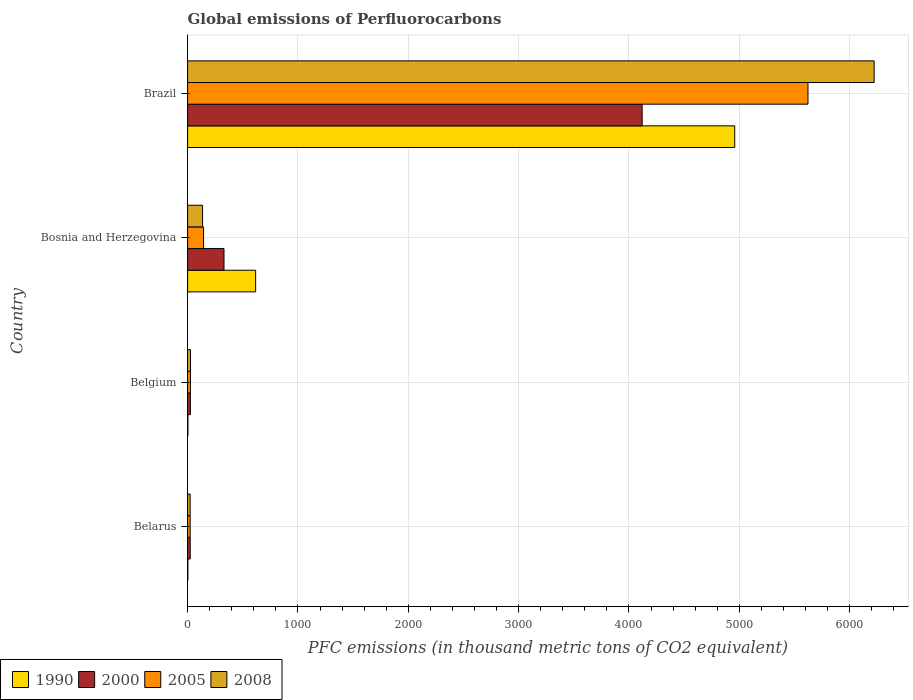How many different coloured bars are there?
Offer a terse response. 4. How many groups of bars are there?
Offer a very short reply. 4. Are the number of bars on each tick of the Y-axis equal?
Give a very brief answer. Yes. What is the label of the 4th group of bars from the top?
Give a very brief answer. Belarus. What is the global emissions of Perfluorocarbons in 1990 in Bosnia and Herzegovina?
Offer a terse response. 616.7. Across all countries, what is the maximum global emissions of Perfluorocarbons in 2008?
Your response must be concise. 6221.8. Across all countries, what is the minimum global emissions of Perfluorocarbons in 2008?
Provide a succinct answer. 23.1. In which country was the global emissions of Perfluorocarbons in 2000 maximum?
Offer a very short reply. Brazil. In which country was the global emissions of Perfluorocarbons in 1990 minimum?
Offer a very short reply. Belarus. What is the total global emissions of Perfluorocarbons in 1990 in the graph?
Provide a short and direct response. 5580.3. What is the difference between the global emissions of Perfluorocarbons in 2008 in Belgium and that in Bosnia and Herzegovina?
Ensure brevity in your answer.  -109.6. What is the difference between the global emissions of Perfluorocarbons in 2000 in Bosnia and Herzegovina and the global emissions of Perfluorocarbons in 2008 in Belgium?
Make the answer very short. 303.9. What is the average global emissions of Perfluorocarbons in 1990 per country?
Your answer should be compact. 1395.08. What is the difference between the global emissions of Perfluorocarbons in 2000 and global emissions of Perfluorocarbons in 2008 in Bosnia and Herzegovina?
Offer a terse response. 194.3. What is the ratio of the global emissions of Perfluorocarbons in 1990 in Belarus to that in Bosnia and Herzegovina?
Ensure brevity in your answer.  0. Is the global emissions of Perfluorocarbons in 2008 in Belarus less than that in Brazil?
Your answer should be compact. Yes. Is the difference between the global emissions of Perfluorocarbons in 2000 in Belarus and Bosnia and Herzegovina greater than the difference between the global emissions of Perfluorocarbons in 2008 in Belarus and Bosnia and Herzegovina?
Ensure brevity in your answer.  No. What is the difference between the highest and the second highest global emissions of Perfluorocarbons in 2005?
Keep it short and to the point. 5477.7. What is the difference between the highest and the lowest global emissions of Perfluorocarbons in 2008?
Offer a very short reply. 6198.7. In how many countries, is the global emissions of Perfluorocarbons in 2008 greater than the average global emissions of Perfluorocarbons in 2008 taken over all countries?
Keep it short and to the point. 1. Is the sum of the global emissions of Perfluorocarbons in 2000 in Belarus and Belgium greater than the maximum global emissions of Perfluorocarbons in 1990 across all countries?
Your answer should be very brief. No. What does the 1st bar from the bottom in Belgium represents?
Give a very brief answer. 1990. Is it the case that in every country, the sum of the global emissions of Perfluorocarbons in 2005 and global emissions of Perfluorocarbons in 2000 is greater than the global emissions of Perfluorocarbons in 1990?
Provide a short and direct response. No. How many bars are there?
Provide a short and direct response. 16. How many countries are there in the graph?
Keep it short and to the point. 4. What is the difference between two consecutive major ticks on the X-axis?
Keep it short and to the point. 1000. Does the graph contain grids?
Offer a terse response. Yes. How many legend labels are there?
Ensure brevity in your answer.  4. How are the legend labels stacked?
Provide a succinct answer. Horizontal. What is the title of the graph?
Your answer should be very brief. Global emissions of Perfluorocarbons. Does "1971" appear as one of the legend labels in the graph?
Ensure brevity in your answer.  No. What is the label or title of the X-axis?
Provide a succinct answer. PFC emissions (in thousand metric tons of CO2 equivalent). What is the label or title of the Y-axis?
Give a very brief answer. Country. What is the PFC emissions (in thousand metric tons of CO2 equivalent) in 1990 in Belarus?
Keep it short and to the point. 2.6. What is the PFC emissions (in thousand metric tons of CO2 equivalent) in 2000 in Belarus?
Your response must be concise. 23.9. What is the PFC emissions (in thousand metric tons of CO2 equivalent) in 2005 in Belarus?
Ensure brevity in your answer.  23.4. What is the PFC emissions (in thousand metric tons of CO2 equivalent) in 2008 in Belarus?
Your answer should be very brief. 23.1. What is the PFC emissions (in thousand metric tons of CO2 equivalent) of 2000 in Belgium?
Provide a short and direct response. 25.2. What is the PFC emissions (in thousand metric tons of CO2 equivalent) of 2005 in Belgium?
Offer a terse response. 25.7. What is the PFC emissions (in thousand metric tons of CO2 equivalent) in 2008 in Belgium?
Give a very brief answer. 26. What is the PFC emissions (in thousand metric tons of CO2 equivalent) of 1990 in Bosnia and Herzegovina?
Ensure brevity in your answer.  616.7. What is the PFC emissions (in thousand metric tons of CO2 equivalent) of 2000 in Bosnia and Herzegovina?
Ensure brevity in your answer.  329.9. What is the PFC emissions (in thousand metric tons of CO2 equivalent) in 2005 in Bosnia and Herzegovina?
Make the answer very short. 144.4. What is the PFC emissions (in thousand metric tons of CO2 equivalent) in 2008 in Bosnia and Herzegovina?
Offer a very short reply. 135.6. What is the PFC emissions (in thousand metric tons of CO2 equivalent) of 1990 in Brazil?
Offer a terse response. 4958.1. What is the PFC emissions (in thousand metric tons of CO2 equivalent) of 2000 in Brazil?
Provide a succinct answer. 4119.1. What is the PFC emissions (in thousand metric tons of CO2 equivalent) in 2005 in Brazil?
Offer a very short reply. 5622.1. What is the PFC emissions (in thousand metric tons of CO2 equivalent) in 2008 in Brazil?
Your answer should be compact. 6221.8. Across all countries, what is the maximum PFC emissions (in thousand metric tons of CO2 equivalent) of 1990?
Your answer should be very brief. 4958.1. Across all countries, what is the maximum PFC emissions (in thousand metric tons of CO2 equivalent) in 2000?
Your answer should be very brief. 4119.1. Across all countries, what is the maximum PFC emissions (in thousand metric tons of CO2 equivalent) of 2005?
Your answer should be compact. 5622.1. Across all countries, what is the maximum PFC emissions (in thousand metric tons of CO2 equivalent) in 2008?
Your answer should be very brief. 6221.8. Across all countries, what is the minimum PFC emissions (in thousand metric tons of CO2 equivalent) of 2000?
Give a very brief answer. 23.9. Across all countries, what is the minimum PFC emissions (in thousand metric tons of CO2 equivalent) of 2005?
Offer a terse response. 23.4. Across all countries, what is the minimum PFC emissions (in thousand metric tons of CO2 equivalent) in 2008?
Offer a terse response. 23.1. What is the total PFC emissions (in thousand metric tons of CO2 equivalent) in 1990 in the graph?
Provide a short and direct response. 5580.3. What is the total PFC emissions (in thousand metric tons of CO2 equivalent) in 2000 in the graph?
Ensure brevity in your answer.  4498.1. What is the total PFC emissions (in thousand metric tons of CO2 equivalent) in 2005 in the graph?
Offer a very short reply. 5815.6. What is the total PFC emissions (in thousand metric tons of CO2 equivalent) of 2008 in the graph?
Your answer should be compact. 6406.5. What is the difference between the PFC emissions (in thousand metric tons of CO2 equivalent) of 1990 in Belarus and that in Belgium?
Make the answer very short. -0.3. What is the difference between the PFC emissions (in thousand metric tons of CO2 equivalent) in 2000 in Belarus and that in Belgium?
Your answer should be compact. -1.3. What is the difference between the PFC emissions (in thousand metric tons of CO2 equivalent) of 2005 in Belarus and that in Belgium?
Provide a succinct answer. -2.3. What is the difference between the PFC emissions (in thousand metric tons of CO2 equivalent) in 1990 in Belarus and that in Bosnia and Herzegovina?
Provide a short and direct response. -614.1. What is the difference between the PFC emissions (in thousand metric tons of CO2 equivalent) of 2000 in Belarus and that in Bosnia and Herzegovina?
Keep it short and to the point. -306. What is the difference between the PFC emissions (in thousand metric tons of CO2 equivalent) of 2005 in Belarus and that in Bosnia and Herzegovina?
Ensure brevity in your answer.  -121. What is the difference between the PFC emissions (in thousand metric tons of CO2 equivalent) in 2008 in Belarus and that in Bosnia and Herzegovina?
Provide a short and direct response. -112.5. What is the difference between the PFC emissions (in thousand metric tons of CO2 equivalent) in 1990 in Belarus and that in Brazil?
Offer a very short reply. -4955.5. What is the difference between the PFC emissions (in thousand metric tons of CO2 equivalent) in 2000 in Belarus and that in Brazil?
Offer a terse response. -4095.2. What is the difference between the PFC emissions (in thousand metric tons of CO2 equivalent) of 2005 in Belarus and that in Brazil?
Provide a succinct answer. -5598.7. What is the difference between the PFC emissions (in thousand metric tons of CO2 equivalent) in 2008 in Belarus and that in Brazil?
Your answer should be very brief. -6198.7. What is the difference between the PFC emissions (in thousand metric tons of CO2 equivalent) in 1990 in Belgium and that in Bosnia and Herzegovina?
Keep it short and to the point. -613.8. What is the difference between the PFC emissions (in thousand metric tons of CO2 equivalent) of 2000 in Belgium and that in Bosnia and Herzegovina?
Offer a very short reply. -304.7. What is the difference between the PFC emissions (in thousand metric tons of CO2 equivalent) in 2005 in Belgium and that in Bosnia and Herzegovina?
Offer a terse response. -118.7. What is the difference between the PFC emissions (in thousand metric tons of CO2 equivalent) in 2008 in Belgium and that in Bosnia and Herzegovina?
Your answer should be very brief. -109.6. What is the difference between the PFC emissions (in thousand metric tons of CO2 equivalent) in 1990 in Belgium and that in Brazil?
Your answer should be very brief. -4955.2. What is the difference between the PFC emissions (in thousand metric tons of CO2 equivalent) of 2000 in Belgium and that in Brazil?
Ensure brevity in your answer.  -4093.9. What is the difference between the PFC emissions (in thousand metric tons of CO2 equivalent) of 2005 in Belgium and that in Brazil?
Provide a short and direct response. -5596.4. What is the difference between the PFC emissions (in thousand metric tons of CO2 equivalent) of 2008 in Belgium and that in Brazil?
Provide a succinct answer. -6195.8. What is the difference between the PFC emissions (in thousand metric tons of CO2 equivalent) of 1990 in Bosnia and Herzegovina and that in Brazil?
Provide a succinct answer. -4341.4. What is the difference between the PFC emissions (in thousand metric tons of CO2 equivalent) in 2000 in Bosnia and Herzegovina and that in Brazil?
Offer a terse response. -3789.2. What is the difference between the PFC emissions (in thousand metric tons of CO2 equivalent) of 2005 in Bosnia and Herzegovina and that in Brazil?
Provide a short and direct response. -5477.7. What is the difference between the PFC emissions (in thousand metric tons of CO2 equivalent) in 2008 in Bosnia and Herzegovina and that in Brazil?
Your answer should be very brief. -6086.2. What is the difference between the PFC emissions (in thousand metric tons of CO2 equivalent) of 1990 in Belarus and the PFC emissions (in thousand metric tons of CO2 equivalent) of 2000 in Belgium?
Offer a very short reply. -22.6. What is the difference between the PFC emissions (in thousand metric tons of CO2 equivalent) of 1990 in Belarus and the PFC emissions (in thousand metric tons of CO2 equivalent) of 2005 in Belgium?
Provide a succinct answer. -23.1. What is the difference between the PFC emissions (in thousand metric tons of CO2 equivalent) of 1990 in Belarus and the PFC emissions (in thousand metric tons of CO2 equivalent) of 2008 in Belgium?
Make the answer very short. -23.4. What is the difference between the PFC emissions (in thousand metric tons of CO2 equivalent) of 2000 in Belarus and the PFC emissions (in thousand metric tons of CO2 equivalent) of 2008 in Belgium?
Provide a succinct answer. -2.1. What is the difference between the PFC emissions (in thousand metric tons of CO2 equivalent) in 2005 in Belarus and the PFC emissions (in thousand metric tons of CO2 equivalent) in 2008 in Belgium?
Make the answer very short. -2.6. What is the difference between the PFC emissions (in thousand metric tons of CO2 equivalent) in 1990 in Belarus and the PFC emissions (in thousand metric tons of CO2 equivalent) in 2000 in Bosnia and Herzegovina?
Keep it short and to the point. -327.3. What is the difference between the PFC emissions (in thousand metric tons of CO2 equivalent) in 1990 in Belarus and the PFC emissions (in thousand metric tons of CO2 equivalent) in 2005 in Bosnia and Herzegovina?
Your answer should be very brief. -141.8. What is the difference between the PFC emissions (in thousand metric tons of CO2 equivalent) of 1990 in Belarus and the PFC emissions (in thousand metric tons of CO2 equivalent) of 2008 in Bosnia and Herzegovina?
Provide a succinct answer. -133. What is the difference between the PFC emissions (in thousand metric tons of CO2 equivalent) in 2000 in Belarus and the PFC emissions (in thousand metric tons of CO2 equivalent) in 2005 in Bosnia and Herzegovina?
Provide a succinct answer. -120.5. What is the difference between the PFC emissions (in thousand metric tons of CO2 equivalent) in 2000 in Belarus and the PFC emissions (in thousand metric tons of CO2 equivalent) in 2008 in Bosnia and Herzegovina?
Make the answer very short. -111.7. What is the difference between the PFC emissions (in thousand metric tons of CO2 equivalent) in 2005 in Belarus and the PFC emissions (in thousand metric tons of CO2 equivalent) in 2008 in Bosnia and Herzegovina?
Offer a very short reply. -112.2. What is the difference between the PFC emissions (in thousand metric tons of CO2 equivalent) in 1990 in Belarus and the PFC emissions (in thousand metric tons of CO2 equivalent) in 2000 in Brazil?
Make the answer very short. -4116.5. What is the difference between the PFC emissions (in thousand metric tons of CO2 equivalent) of 1990 in Belarus and the PFC emissions (in thousand metric tons of CO2 equivalent) of 2005 in Brazil?
Your answer should be compact. -5619.5. What is the difference between the PFC emissions (in thousand metric tons of CO2 equivalent) of 1990 in Belarus and the PFC emissions (in thousand metric tons of CO2 equivalent) of 2008 in Brazil?
Your answer should be very brief. -6219.2. What is the difference between the PFC emissions (in thousand metric tons of CO2 equivalent) of 2000 in Belarus and the PFC emissions (in thousand metric tons of CO2 equivalent) of 2005 in Brazil?
Make the answer very short. -5598.2. What is the difference between the PFC emissions (in thousand metric tons of CO2 equivalent) in 2000 in Belarus and the PFC emissions (in thousand metric tons of CO2 equivalent) in 2008 in Brazil?
Your answer should be compact. -6197.9. What is the difference between the PFC emissions (in thousand metric tons of CO2 equivalent) of 2005 in Belarus and the PFC emissions (in thousand metric tons of CO2 equivalent) of 2008 in Brazil?
Your answer should be very brief. -6198.4. What is the difference between the PFC emissions (in thousand metric tons of CO2 equivalent) of 1990 in Belgium and the PFC emissions (in thousand metric tons of CO2 equivalent) of 2000 in Bosnia and Herzegovina?
Ensure brevity in your answer.  -327. What is the difference between the PFC emissions (in thousand metric tons of CO2 equivalent) in 1990 in Belgium and the PFC emissions (in thousand metric tons of CO2 equivalent) in 2005 in Bosnia and Herzegovina?
Offer a terse response. -141.5. What is the difference between the PFC emissions (in thousand metric tons of CO2 equivalent) in 1990 in Belgium and the PFC emissions (in thousand metric tons of CO2 equivalent) in 2008 in Bosnia and Herzegovina?
Provide a short and direct response. -132.7. What is the difference between the PFC emissions (in thousand metric tons of CO2 equivalent) of 2000 in Belgium and the PFC emissions (in thousand metric tons of CO2 equivalent) of 2005 in Bosnia and Herzegovina?
Your response must be concise. -119.2. What is the difference between the PFC emissions (in thousand metric tons of CO2 equivalent) in 2000 in Belgium and the PFC emissions (in thousand metric tons of CO2 equivalent) in 2008 in Bosnia and Herzegovina?
Offer a terse response. -110.4. What is the difference between the PFC emissions (in thousand metric tons of CO2 equivalent) of 2005 in Belgium and the PFC emissions (in thousand metric tons of CO2 equivalent) of 2008 in Bosnia and Herzegovina?
Your response must be concise. -109.9. What is the difference between the PFC emissions (in thousand metric tons of CO2 equivalent) of 1990 in Belgium and the PFC emissions (in thousand metric tons of CO2 equivalent) of 2000 in Brazil?
Ensure brevity in your answer.  -4116.2. What is the difference between the PFC emissions (in thousand metric tons of CO2 equivalent) of 1990 in Belgium and the PFC emissions (in thousand metric tons of CO2 equivalent) of 2005 in Brazil?
Your answer should be compact. -5619.2. What is the difference between the PFC emissions (in thousand metric tons of CO2 equivalent) of 1990 in Belgium and the PFC emissions (in thousand metric tons of CO2 equivalent) of 2008 in Brazil?
Your answer should be very brief. -6218.9. What is the difference between the PFC emissions (in thousand metric tons of CO2 equivalent) in 2000 in Belgium and the PFC emissions (in thousand metric tons of CO2 equivalent) in 2005 in Brazil?
Your response must be concise. -5596.9. What is the difference between the PFC emissions (in thousand metric tons of CO2 equivalent) of 2000 in Belgium and the PFC emissions (in thousand metric tons of CO2 equivalent) of 2008 in Brazil?
Offer a very short reply. -6196.6. What is the difference between the PFC emissions (in thousand metric tons of CO2 equivalent) in 2005 in Belgium and the PFC emissions (in thousand metric tons of CO2 equivalent) in 2008 in Brazil?
Your answer should be compact. -6196.1. What is the difference between the PFC emissions (in thousand metric tons of CO2 equivalent) of 1990 in Bosnia and Herzegovina and the PFC emissions (in thousand metric tons of CO2 equivalent) of 2000 in Brazil?
Offer a terse response. -3502.4. What is the difference between the PFC emissions (in thousand metric tons of CO2 equivalent) of 1990 in Bosnia and Herzegovina and the PFC emissions (in thousand metric tons of CO2 equivalent) of 2005 in Brazil?
Your response must be concise. -5005.4. What is the difference between the PFC emissions (in thousand metric tons of CO2 equivalent) of 1990 in Bosnia and Herzegovina and the PFC emissions (in thousand metric tons of CO2 equivalent) of 2008 in Brazil?
Offer a terse response. -5605.1. What is the difference between the PFC emissions (in thousand metric tons of CO2 equivalent) of 2000 in Bosnia and Herzegovina and the PFC emissions (in thousand metric tons of CO2 equivalent) of 2005 in Brazil?
Ensure brevity in your answer.  -5292.2. What is the difference between the PFC emissions (in thousand metric tons of CO2 equivalent) of 2000 in Bosnia and Herzegovina and the PFC emissions (in thousand metric tons of CO2 equivalent) of 2008 in Brazil?
Give a very brief answer. -5891.9. What is the difference between the PFC emissions (in thousand metric tons of CO2 equivalent) in 2005 in Bosnia and Herzegovina and the PFC emissions (in thousand metric tons of CO2 equivalent) in 2008 in Brazil?
Offer a terse response. -6077.4. What is the average PFC emissions (in thousand metric tons of CO2 equivalent) in 1990 per country?
Make the answer very short. 1395.08. What is the average PFC emissions (in thousand metric tons of CO2 equivalent) in 2000 per country?
Offer a terse response. 1124.53. What is the average PFC emissions (in thousand metric tons of CO2 equivalent) in 2005 per country?
Offer a terse response. 1453.9. What is the average PFC emissions (in thousand metric tons of CO2 equivalent) in 2008 per country?
Provide a succinct answer. 1601.62. What is the difference between the PFC emissions (in thousand metric tons of CO2 equivalent) of 1990 and PFC emissions (in thousand metric tons of CO2 equivalent) of 2000 in Belarus?
Make the answer very short. -21.3. What is the difference between the PFC emissions (in thousand metric tons of CO2 equivalent) of 1990 and PFC emissions (in thousand metric tons of CO2 equivalent) of 2005 in Belarus?
Your answer should be very brief. -20.8. What is the difference between the PFC emissions (in thousand metric tons of CO2 equivalent) of 1990 and PFC emissions (in thousand metric tons of CO2 equivalent) of 2008 in Belarus?
Your answer should be very brief. -20.5. What is the difference between the PFC emissions (in thousand metric tons of CO2 equivalent) in 2000 and PFC emissions (in thousand metric tons of CO2 equivalent) in 2005 in Belarus?
Make the answer very short. 0.5. What is the difference between the PFC emissions (in thousand metric tons of CO2 equivalent) of 2000 and PFC emissions (in thousand metric tons of CO2 equivalent) of 2008 in Belarus?
Your answer should be very brief. 0.8. What is the difference between the PFC emissions (in thousand metric tons of CO2 equivalent) in 2005 and PFC emissions (in thousand metric tons of CO2 equivalent) in 2008 in Belarus?
Make the answer very short. 0.3. What is the difference between the PFC emissions (in thousand metric tons of CO2 equivalent) in 1990 and PFC emissions (in thousand metric tons of CO2 equivalent) in 2000 in Belgium?
Your answer should be very brief. -22.3. What is the difference between the PFC emissions (in thousand metric tons of CO2 equivalent) in 1990 and PFC emissions (in thousand metric tons of CO2 equivalent) in 2005 in Belgium?
Your response must be concise. -22.8. What is the difference between the PFC emissions (in thousand metric tons of CO2 equivalent) in 1990 and PFC emissions (in thousand metric tons of CO2 equivalent) in 2008 in Belgium?
Give a very brief answer. -23.1. What is the difference between the PFC emissions (in thousand metric tons of CO2 equivalent) in 2000 and PFC emissions (in thousand metric tons of CO2 equivalent) in 2005 in Belgium?
Offer a very short reply. -0.5. What is the difference between the PFC emissions (in thousand metric tons of CO2 equivalent) in 1990 and PFC emissions (in thousand metric tons of CO2 equivalent) in 2000 in Bosnia and Herzegovina?
Offer a terse response. 286.8. What is the difference between the PFC emissions (in thousand metric tons of CO2 equivalent) in 1990 and PFC emissions (in thousand metric tons of CO2 equivalent) in 2005 in Bosnia and Herzegovina?
Your response must be concise. 472.3. What is the difference between the PFC emissions (in thousand metric tons of CO2 equivalent) of 1990 and PFC emissions (in thousand metric tons of CO2 equivalent) of 2008 in Bosnia and Herzegovina?
Your answer should be very brief. 481.1. What is the difference between the PFC emissions (in thousand metric tons of CO2 equivalent) in 2000 and PFC emissions (in thousand metric tons of CO2 equivalent) in 2005 in Bosnia and Herzegovina?
Give a very brief answer. 185.5. What is the difference between the PFC emissions (in thousand metric tons of CO2 equivalent) in 2000 and PFC emissions (in thousand metric tons of CO2 equivalent) in 2008 in Bosnia and Herzegovina?
Ensure brevity in your answer.  194.3. What is the difference between the PFC emissions (in thousand metric tons of CO2 equivalent) in 1990 and PFC emissions (in thousand metric tons of CO2 equivalent) in 2000 in Brazil?
Offer a terse response. 839. What is the difference between the PFC emissions (in thousand metric tons of CO2 equivalent) of 1990 and PFC emissions (in thousand metric tons of CO2 equivalent) of 2005 in Brazil?
Make the answer very short. -664. What is the difference between the PFC emissions (in thousand metric tons of CO2 equivalent) of 1990 and PFC emissions (in thousand metric tons of CO2 equivalent) of 2008 in Brazil?
Keep it short and to the point. -1263.7. What is the difference between the PFC emissions (in thousand metric tons of CO2 equivalent) of 2000 and PFC emissions (in thousand metric tons of CO2 equivalent) of 2005 in Brazil?
Give a very brief answer. -1503. What is the difference between the PFC emissions (in thousand metric tons of CO2 equivalent) in 2000 and PFC emissions (in thousand metric tons of CO2 equivalent) in 2008 in Brazil?
Offer a terse response. -2102.7. What is the difference between the PFC emissions (in thousand metric tons of CO2 equivalent) in 2005 and PFC emissions (in thousand metric tons of CO2 equivalent) in 2008 in Brazil?
Provide a short and direct response. -599.7. What is the ratio of the PFC emissions (in thousand metric tons of CO2 equivalent) of 1990 in Belarus to that in Belgium?
Your answer should be very brief. 0.9. What is the ratio of the PFC emissions (in thousand metric tons of CO2 equivalent) of 2000 in Belarus to that in Belgium?
Your answer should be compact. 0.95. What is the ratio of the PFC emissions (in thousand metric tons of CO2 equivalent) in 2005 in Belarus to that in Belgium?
Your response must be concise. 0.91. What is the ratio of the PFC emissions (in thousand metric tons of CO2 equivalent) of 2008 in Belarus to that in Belgium?
Give a very brief answer. 0.89. What is the ratio of the PFC emissions (in thousand metric tons of CO2 equivalent) in 1990 in Belarus to that in Bosnia and Herzegovina?
Offer a terse response. 0. What is the ratio of the PFC emissions (in thousand metric tons of CO2 equivalent) in 2000 in Belarus to that in Bosnia and Herzegovina?
Your answer should be very brief. 0.07. What is the ratio of the PFC emissions (in thousand metric tons of CO2 equivalent) of 2005 in Belarus to that in Bosnia and Herzegovina?
Offer a terse response. 0.16. What is the ratio of the PFC emissions (in thousand metric tons of CO2 equivalent) of 2008 in Belarus to that in Bosnia and Herzegovina?
Ensure brevity in your answer.  0.17. What is the ratio of the PFC emissions (in thousand metric tons of CO2 equivalent) in 2000 in Belarus to that in Brazil?
Your answer should be compact. 0.01. What is the ratio of the PFC emissions (in thousand metric tons of CO2 equivalent) in 2005 in Belarus to that in Brazil?
Make the answer very short. 0. What is the ratio of the PFC emissions (in thousand metric tons of CO2 equivalent) in 2008 in Belarus to that in Brazil?
Offer a very short reply. 0. What is the ratio of the PFC emissions (in thousand metric tons of CO2 equivalent) of 1990 in Belgium to that in Bosnia and Herzegovina?
Your answer should be compact. 0. What is the ratio of the PFC emissions (in thousand metric tons of CO2 equivalent) in 2000 in Belgium to that in Bosnia and Herzegovina?
Keep it short and to the point. 0.08. What is the ratio of the PFC emissions (in thousand metric tons of CO2 equivalent) of 2005 in Belgium to that in Bosnia and Herzegovina?
Make the answer very short. 0.18. What is the ratio of the PFC emissions (in thousand metric tons of CO2 equivalent) of 2008 in Belgium to that in Bosnia and Herzegovina?
Provide a short and direct response. 0.19. What is the ratio of the PFC emissions (in thousand metric tons of CO2 equivalent) of 1990 in Belgium to that in Brazil?
Give a very brief answer. 0. What is the ratio of the PFC emissions (in thousand metric tons of CO2 equivalent) in 2000 in Belgium to that in Brazil?
Provide a succinct answer. 0.01. What is the ratio of the PFC emissions (in thousand metric tons of CO2 equivalent) of 2005 in Belgium to that in Brazil?
Ensure brevity in your answer.  0. What is the ratio of the PFC emissions (in thousand metric tons of CO2 equivalent) of 2008 in Belgium to that in Brazil?
Offer a terse response. 0. What is the ratio of the PFC emissions (in thousand metric tons of CO2 equivalent) of 1990 in Bosnia and Herzegovina to that in Brazil?
Provide a succinct answer. 0.12. What is the ratio of the PFC emissions (in thousand metric tons of CO2 equivalent) in 2000 in Bosnia and Herzegovina to that in Brazil?
Offer a very short reply. 0.08. What is the ratio of the PFC emissions (in thousand metric tons of CO2 equivalent) in 2005 in Bosnia and Herzegovina to that in Brazil?
Ensure brevity in your answer.  0.03. What is the ratio of the PFC emissions (in thousand metric tons of CO2 equivalent) of 2008 in Bosnia and Herzegovina to that in Brazil?
Your answer should be very brief. 0.02. What is the difference between the highest and the second highest PFC emissions (in thousand metric tons of CO2 equivalent) in 1990?
Your answer should be very brief. 4341.4. What is the difference between the highest and the second highest PFC emissions (in thousand metric tons of CO2 equivalent) in 2000?
Provide a succinct answer. 3789.2. What is the difference between the highest and the second highest PFC emissions (in thousand metric tons of CO2 equivalent) of 2005?
Offer a terse response. 5477.7. What is the difference between the highest and the second highest PFC emissions (in thousand metric tons of CO2 equivalent) of 2008?
Offer a terse response. 6086.2. What is the difference between the highest and the lowest PFC emissions (in thousand metric tons of CO2 equivalent) in 1990?
Offer a very short reply. 4955.5. What is the difference between the highest and the lowest PFC emissions (in thousand metric tons of CO2 equivalent) of 2000?
Make the answer very short. 4095.2. What is the difference between the highest and the lowest PFC emissions (in thousand metric tons of CO2 equivalent) of 2005?
Provide a succinct answer. 5598.7. What is the difference between the highest and the lowest PFC emissions (in thousand metric tons of CO2 equivalent) in 2008?
Offer a very short reply. 6198.7. 